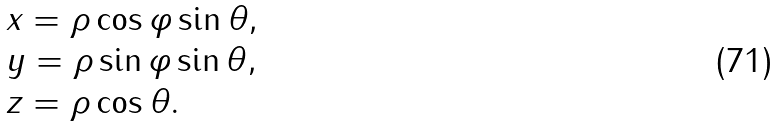Convert formula to latex. <formula><loc_0><loc_0><loc_500><loc_500>\begin{array} { l } x = \rho \cos \varphi \sin \theta , \\ y = \rho \sin \varphi \sin \theta , \\ z = \rho \cos \theta . \\ \end{array}</formula> 